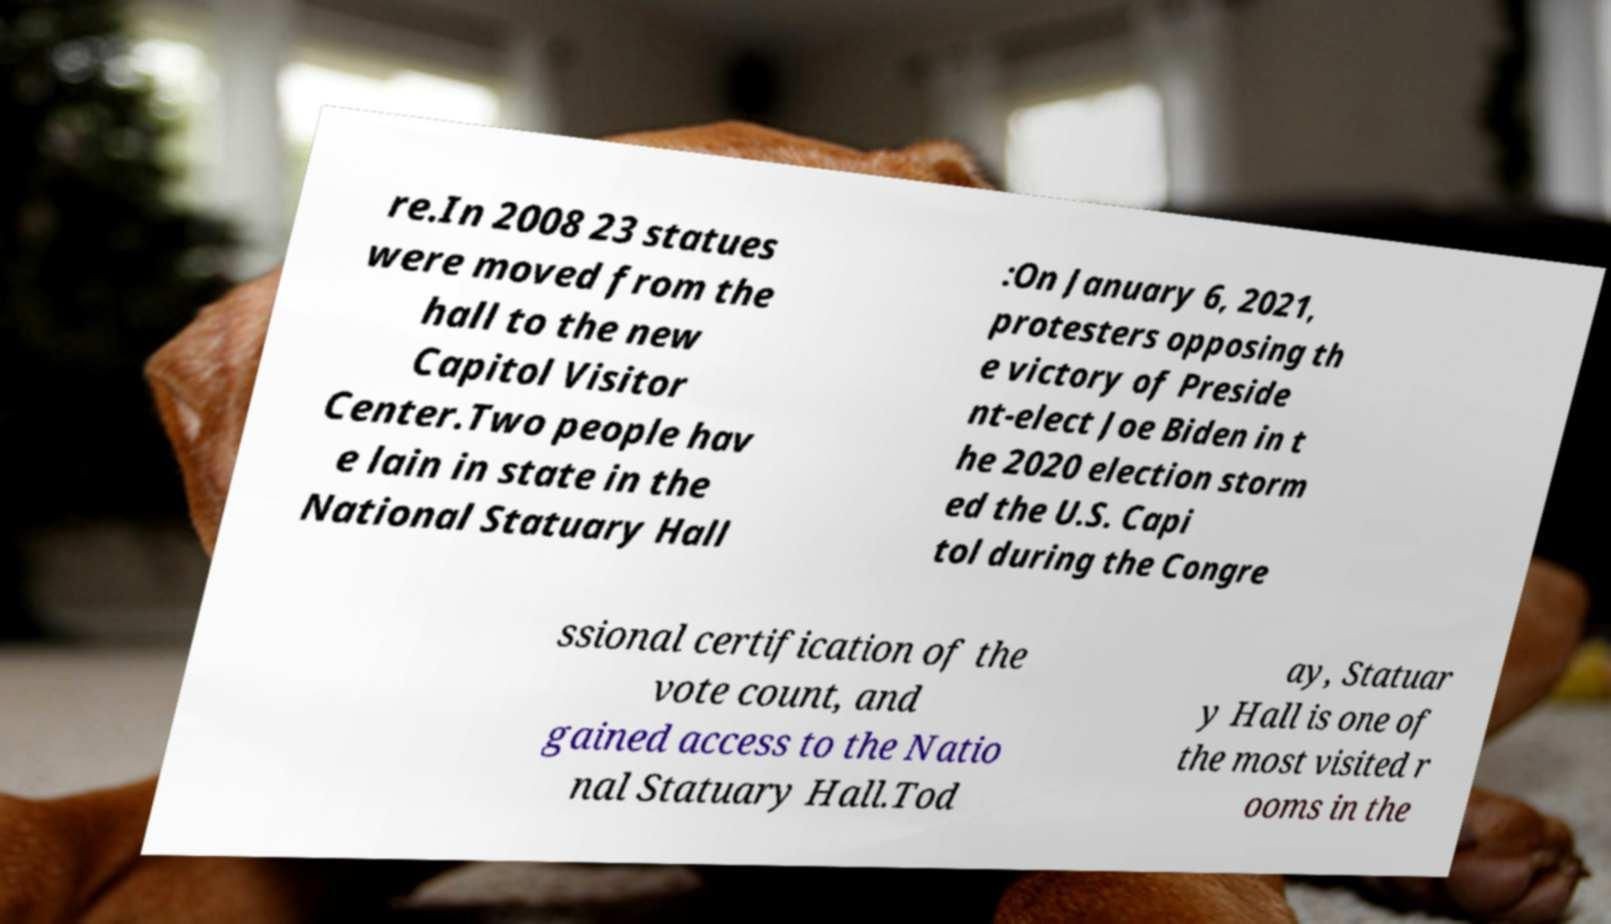Could you extract and type out the text from this image? re.In 2008 23 statues were moved from the hall to the new Capitol Visitor Center.Two people hav e lain in state in the National Statuary Hall :On January 6, 2021, protesters opposing th e victory of Preside nt-elect Joe Biden in t he 2020 election storm ed the U.S. Capi tol during the Congre ssional certification of the vote count, and gained access to the Natio nal Statuary Hall.Tod ay, Statuar y Hall is one of the most visited r ooms in the 